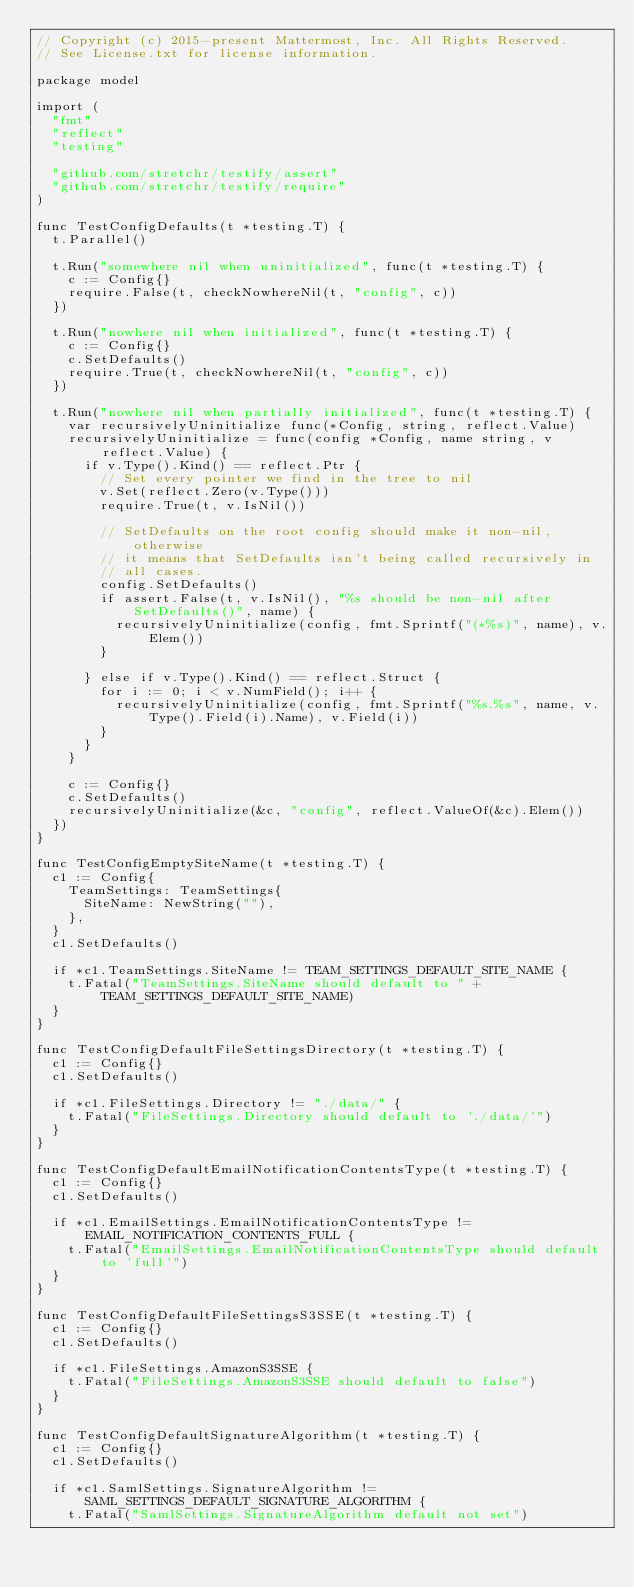Convert code to text. <code><loc_0><loc_0><loc_500><loc_500><_Go_>// Copyright (c) 2015-present Mattermost, Inc. All Rights Reserved.
// See License.txt for license information.

package model

import (
	"fmt"
	"reflect"
	"testing"

	"github.com/stretchr/testify/assert"
	"github.com/stretchr/testify/require"
)

func TestConfigDefaults(t *testing.T) {
	t.Parallel()

	t.Run("somewhere nil when uninitialized", func(t *testing.T) {
		c := Config{}
		require.False(t, checkNowhereNil(t, "config", c))
	})

	t.Run("nowhere nil when initialized", func(t *testing.T) {
		c := Config{}
		c.SetDefaults()
		require.True(t, checkNowhereNil(t, "config", c))
	})

	t.Run("nowhere nil when partially initialized", func(t *testing.T) {
		var recursivelyUninitialize func(*Config, string, reflect.Value)
		recursivelyUninitialize = func(config *Config, name string, v reflect.Value) {
			if v.Type().Kind() == reflect.Ptr {
				// Set every pointer we find in the tree to nil
				v.Set(reflect.Zero(v.Type()))
				require.True(t, v.IsNil())

				// SetDefaults on the root config should make it non-nil, otherwise
				// it means that SetDefaults isn't being called recursively in
				// all cases.
				config.SetDefaults()
				if assert.False(t, v.IsNil(), "%s should be non-nil after SetDefaults()", name) {
					recursivelyUninitialize(config, fmt.Sprintf("(*%s)", name), v.Elem())
				}

			} else if v.Type().Kind() == reflect.Struct {
				for i := 0; i < v.NumField(); i++ {
					recursivelyUninitialize(config, fmt.Sprintf("%s.%s", name, v.Type().Field(i).Name), v.Field(i))
				}
			}
		}

		c := Config{}
		c.SetDefaults()
		recursivelyUninitialize(&c, "config", reflect.ValueOf(&c).Elem())
	})
}

func TestConfigEmptySiteName(t *testing.T) {
	c1 := Config{
		TeamSettings: TeamSettings{
			SiteName: NewString(""),
		},
	}
	c1.SetDefaults()

	if *c1.TeamSettings.SiteName != TEAM_SETTINGS_DEFAULT_SITE_NAME {
		t.Fatal("TeamSettings.SiteName should default to " + TEAM_SETTINGS_DEFAULT_SITE_NAME)
	}
}

func TestConfigDefaultFileSettingsDirectory(t *testing.T) {
	c1 := Config{}
	c1.SetDefaults()

	if *c1.FileSettings.Directory != "./data/" {
		t.Fatal("FileSettings.Directory should default to './data/'")
	}
}

func TestConfigDefaultEmailNotificationContentsType(t *testing.T) {
	c1 := Config{}
	c1.SetDefaults()

	if *c1.EmailSettings.EmailNotificationContentsType != EMAIL_NOTIFICATION_CONTENTS_FULL {
		t.Fatal("EmailSettings.EmailNotificationContentsType should default to 'full'")
	}
}

func TestConfigDefaultFileSettingsS3SSE(t *testing.T) {
	c1 := Config{}
	c1.SetDefaults()

	if *c1.FileSettings.AmazonS3SSE {
		t.Fatal("FileSettings.AmazonS3SSE should default to false")
	}
}

func TestConfigDefaultSignatureAlgorithm(t *testing.T) {
	c1 := Config{}
	c1.SetDefaults()

	if *c1.SamlSettings.SignatureAlgorithm != SAML_SETTINGS_DEFAULT_SIGNATURE_ALGORITHM {
		t.Fatal("SamlSettings.SignatureAlgorithm default not set")</code> 